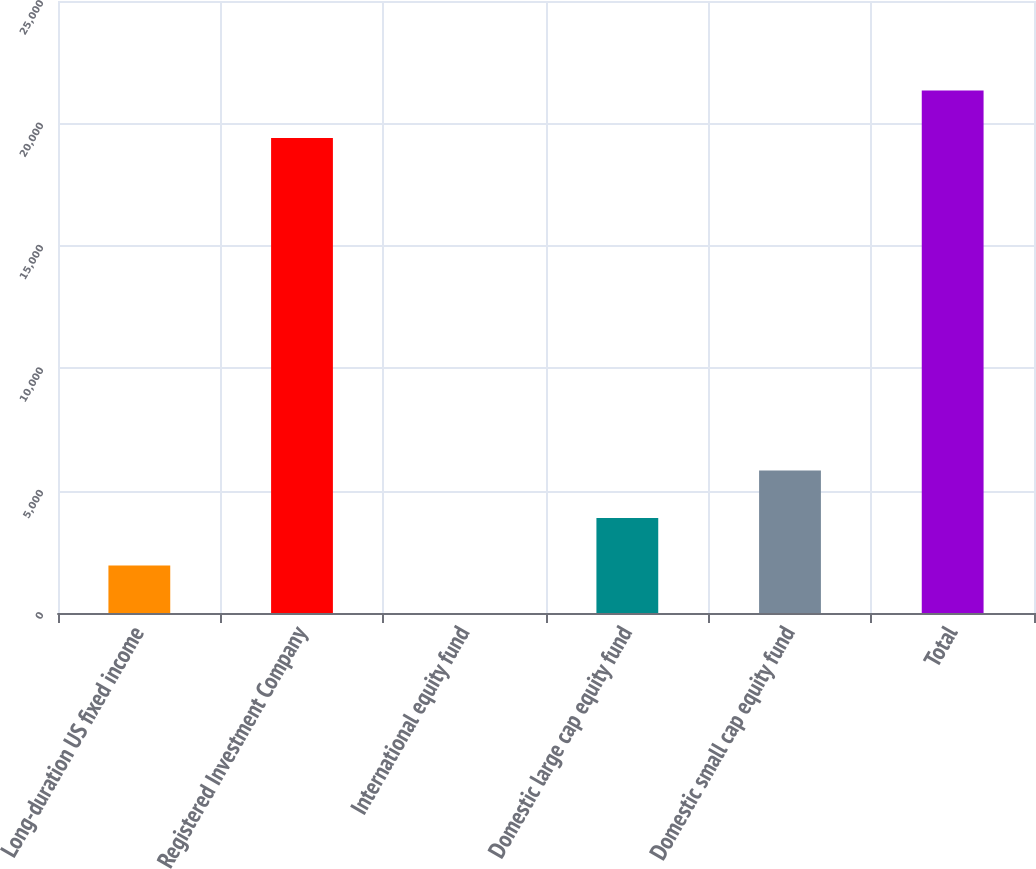<chart> <loc_0><loc_0><loc_500><loc_500><bar_chart><fcel>Long-duration US fixed income<fcel>Registered Investment Company<fcel>International equity fund<fcel>Domestic large cap equity fund<fcel>Domestic small cap equity fund<fcel>Total<nl><fcel>1941.74<fcel>19400<fcel>1.93<fcel>3881.55<fcel>5821.36<fcel>21339.8<nl></chart> 